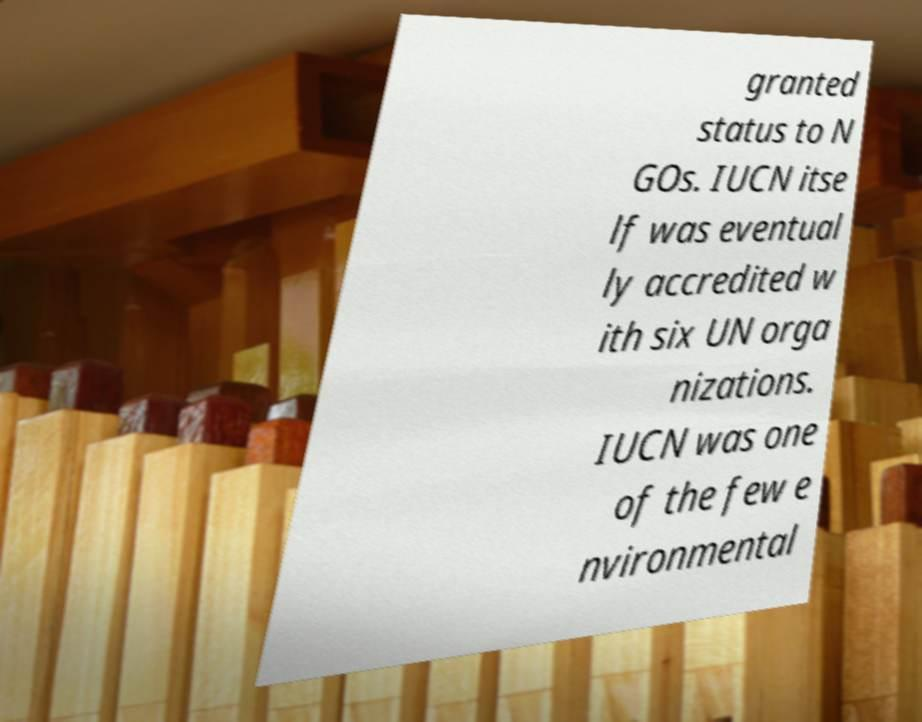Please read and relay the text visible in this image. What does it say? granted status to N GOs. IUCN itse lf was eventual ly accredited w ith six UN orga nizations. IUCN was one of the few e nvironmental 